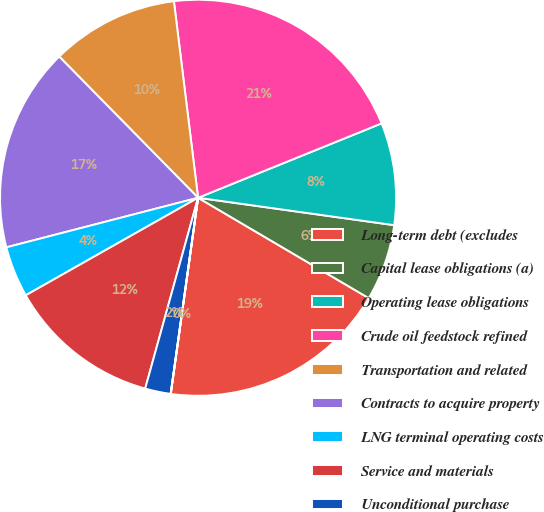<chart> <loc_0><loc_0><loc_500><loc_500><pie_chart><fcel>Long-term debt (excludes<fcel>Capital lease obligations (a)<fcel>Operating lease obligations<fcel>Crude oil feedstock refined<fcel>Transportation and related<fcel>Contracts to acquire property<fcel>LNG terminal operating costs<fcel>Service and materials<fcel>Unconditional purchase<fcel>Commitments for oil and gas<nl><fcel>18.74%<fcel>6.25%<fcel>8.34%<fcel>20.82%<fcel>10.42%<fcel>16.66%<fcel>4.17%<fcel>12.5%<fcel>2.09%<fcel>0.01%<nl></chart> 